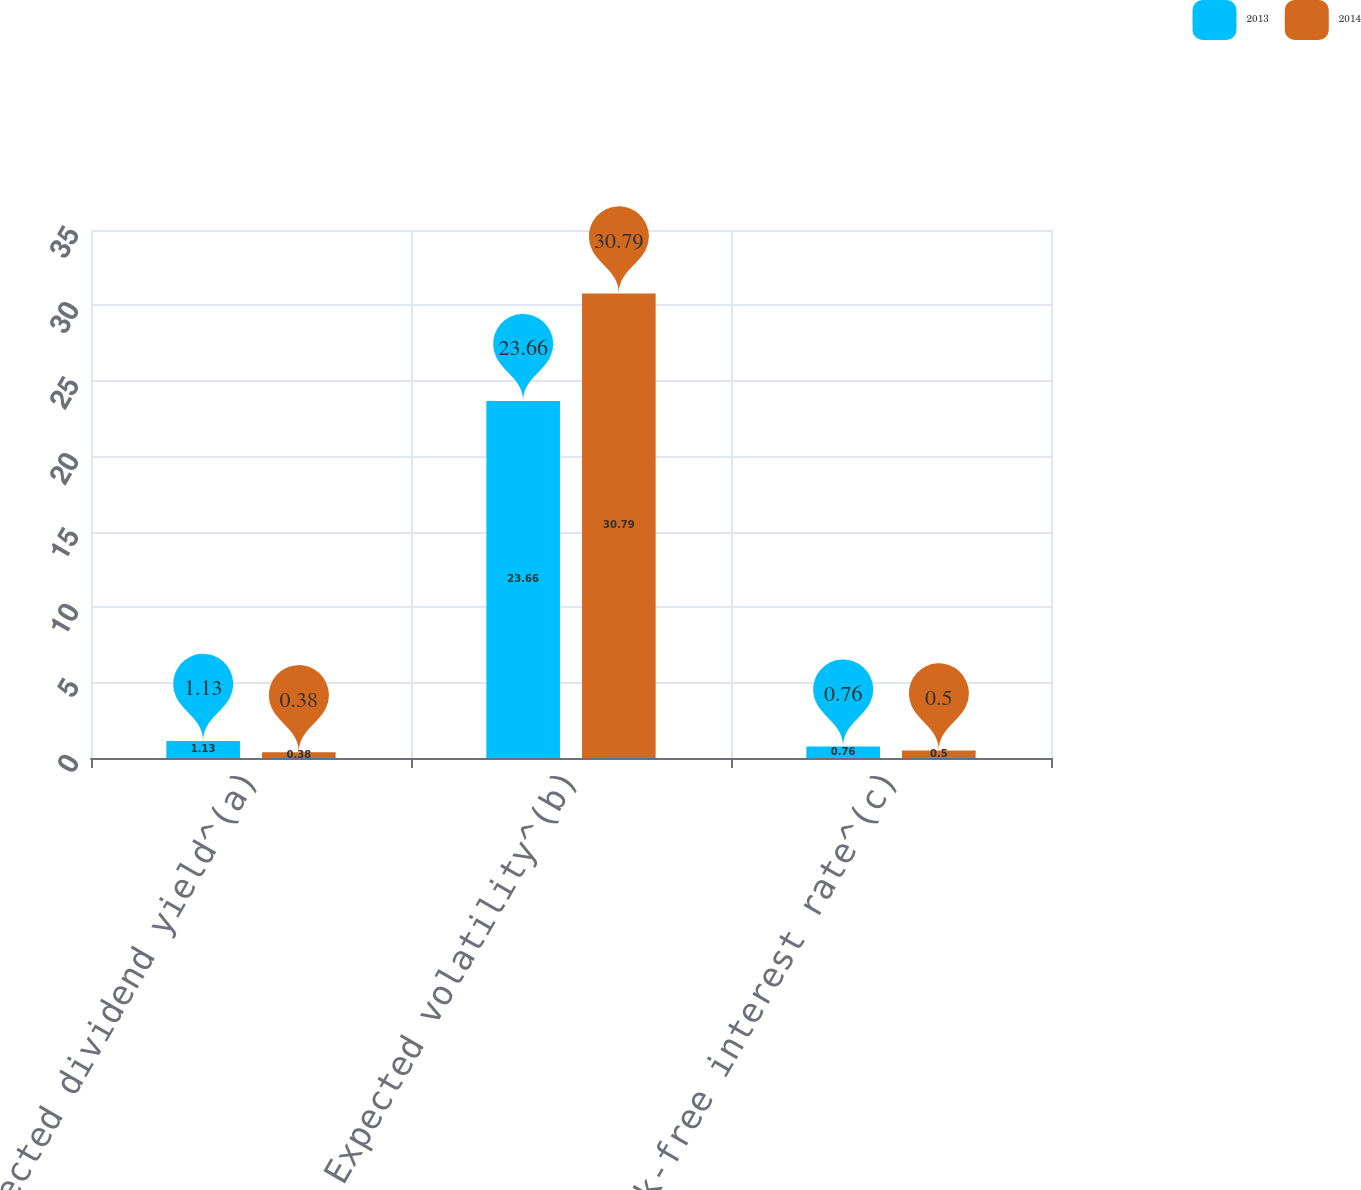<chart> <loc_0><loc_0><loc_500><loc_500><stacked_bar_chart><ecel><fcel>Expected dividend yield^(a)<fcel>Expected volatility^(b)<fcel>Risk-free interest rate^(c)<nl><fcel>2013<fcel>1.13<fcel>23.66<fcel>0.76<nl><fcel>2014<fcel>0.38<fcel>30.79<fcel>0.5<nl></chart> 